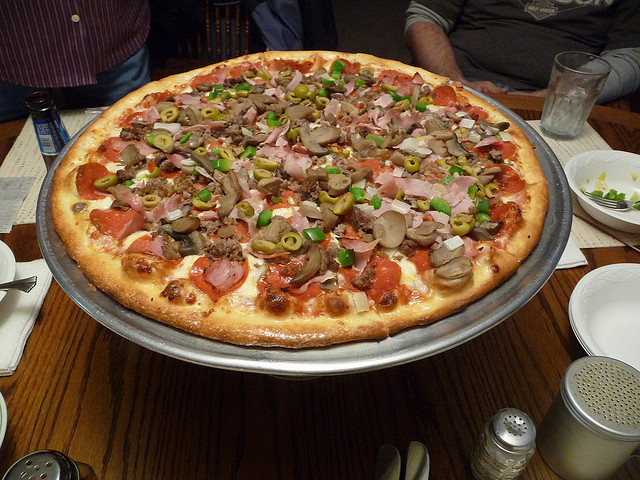Could you suggest a drink that pairs well with this pizza? Considering the rich flavors from the variety of meats and vegetables, a light beer or a soft drink like cola could pair nicely to cleanse the palate between bites. 